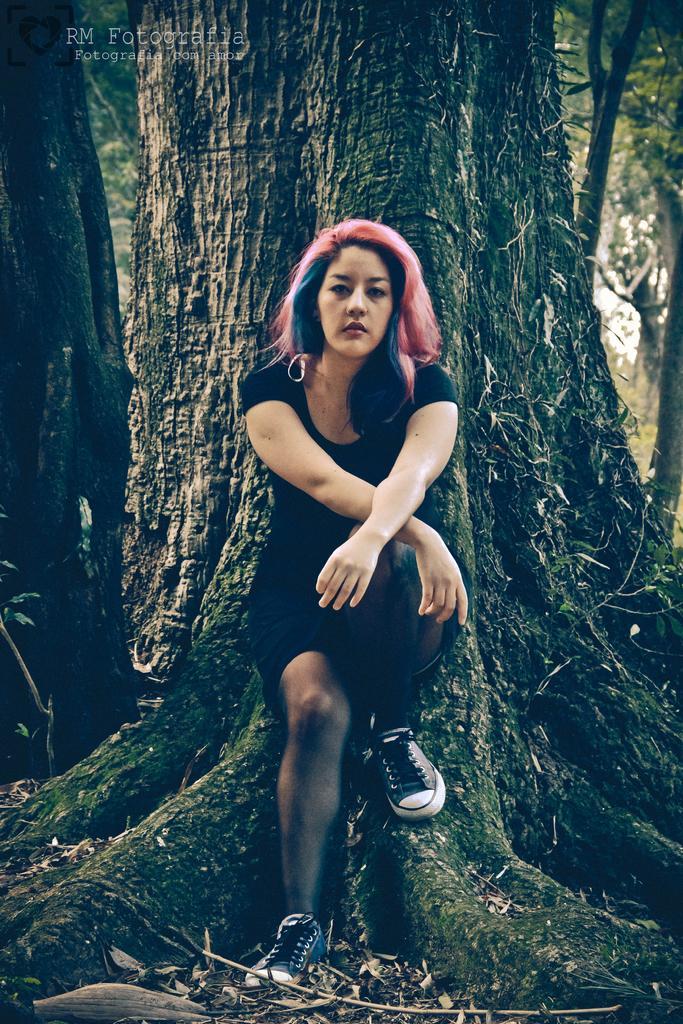Could you give a brief overview of what you see in this image? In this picture we can see a woman and in the background we can see trees, in the top left we can see some text. 